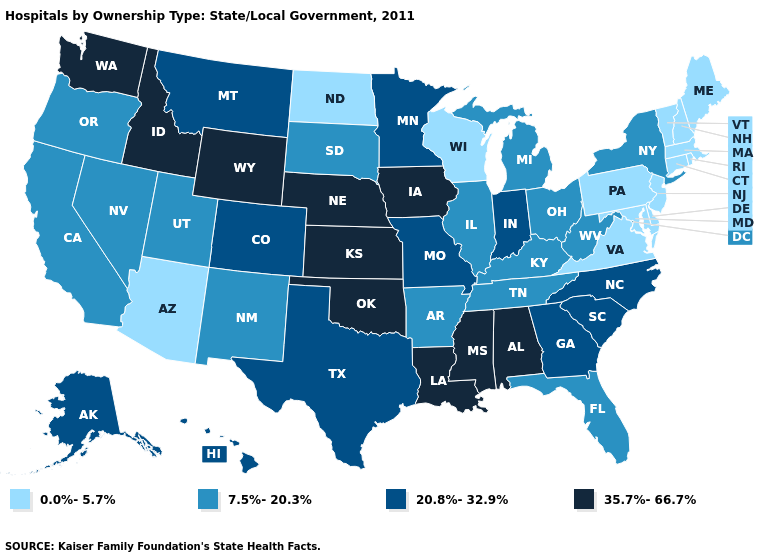Does Ohio have the lowest value in the MidWest?
Give a very brief answer. No. Does Missouri have the same value as Indiana?
Answer briefly. Yes. Name the states that have a value in the range 7.5%-20.3%?
Keep it brief. Arkansas, California, Florida, Illinois, Kentucky, Michigan, Nevada, New Mexico, New York, Ohio, Oregon, South Dakota, Tennessee, Utah, West Virginia. Which states hav the highest value in the Northeast?
Give a very brief answer. New York. What is the highest value in states that border Connecticut?
Quick response, please. 7.5%-20.3%. Name the states that have a value in the range 35.7%-66.7%?
Answer briefly. Alabama, Idaho, Iowa, Kansas, Louisiana, Mississippi, Nebraska, Oklahoma, Washington, Wyoming. Which states hav the highest value in the MidWest?
Keep it brief. Iowa, Kansas, Nebraska. What is the value of North Carolina?
Answer briefly. 20.8%-32.9%. What is the value of Massachusetts?
Answer briefly. 0.0%-5.7%. Among the states that border Arizona , does Colorado have the highest value?
Be succinct. Yes. Name the states that have a value in the range 20.8%-32.9%?
Concise answer only. Alaska, Colorado, Georgia, Hawaii, Indiana, Minnesota, Missouri, Montana, North Carolina, South Carolina, Texas. Among the states that border Oklahoma , does Kansas have the lowest value?
Give a very brief answer. No. Which states have the highest value in the USA?
Be succinct. Alabama, Idaho, Iowa, Kansas, Louisiana, Mississippi, Nebraska, Oklahoma, Washington, Wyoming. Name the states that have a value in the range 20.8%-32.9%?
Short answer required. Alaska, Colorado, Georgia, Hawaii, Indiana, Minnesota, Missouri, Montana, North Carolina, South Carolina, Texas. Does Wisconsin have the same value as Arizona?
Short answer required. Yes. 